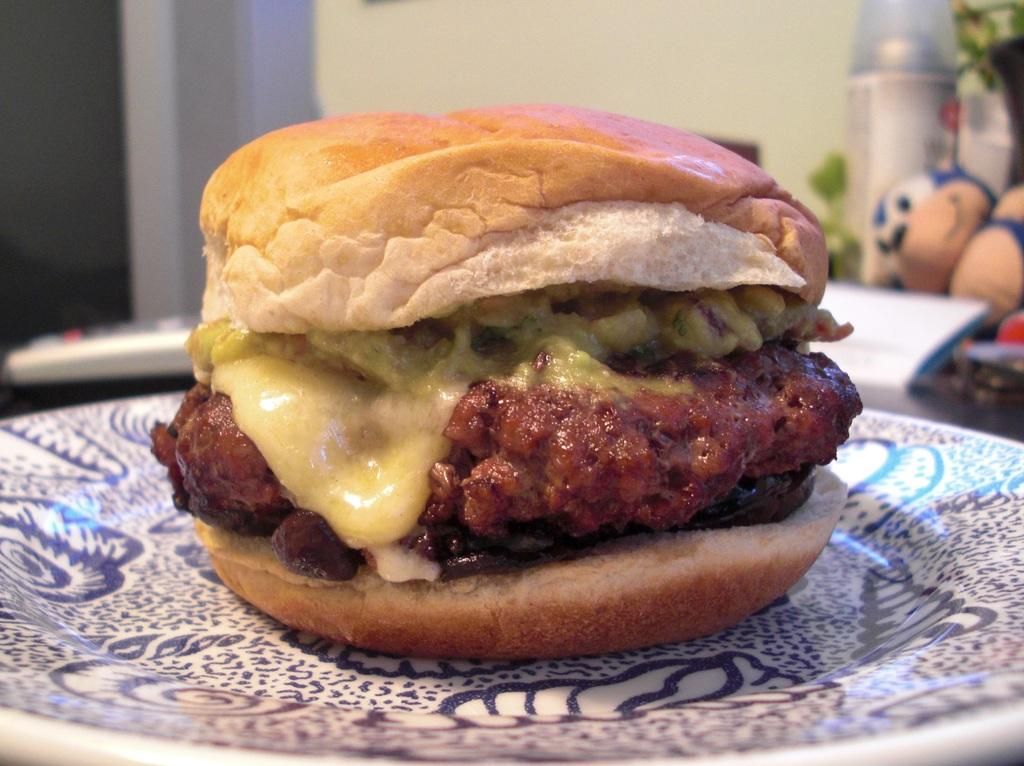What type of food is on the plate in the image? There is a burger on a plate in the image. What electronic device is visible in the image? There is a remote in the image. What type of toy is present in the image? There is a soft toy in the image. Where are the objects placed in the image? The objects are placed on a table in the image. What can be seen in the background of the image? There is a wall visible in the background of the image. What type of stocking is hanging on the wall in the image? There is no stocking present in the image; only a burger, remote, soft toy, table, and wall are visible. How does the rice transport itself in the image? There is no rice present in the image, so it cannot be transported. 